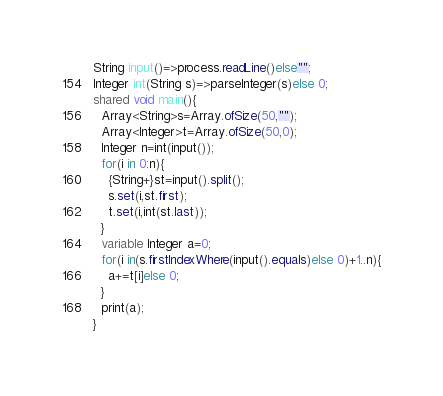<code> <loc_0><loc_0><loc_500><loc_500><_Ceylon_>String input()=>process.readLine()else""; 
Integer int(String s)=>parseInteger(s)else 0;
shared void main(){
  Array<String>s=Array.ofSize(50,"");
  Array<Integer>t=Array.ofSize(50,0);
  Integer n=int(input());
  for(i in 0:n){
    {String+}st=input().split();
    s.set(i,st.first);
    t.set(i,int(st.last));
  }
  variable Integer a=0;
  for(i in(s.firstIndexWhere(input().equals)else 0)+1..n){
    a+=t[i]else 0;
  }
  print(a);
}
</code> 